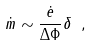Convert formula to latex. <formula><loc_0><loc_0><loc_500><loc_500>\dot { m } \sim \frac { \dot { e } } { \Delta \Phi } \delta \ ,</formula> 